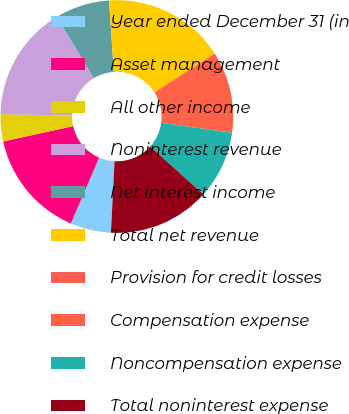Convert chart. <chart><loc_0><loc_0><loc_500><loc_500><pie_chart><fcel>Year ended December 31 (in<fcel>Asset management<fcel>All other income<fcel>Noninterest revenue<fcel>Net interest income<fcel>Total net revenue<fcel>Provision for credit losses<fcel>Compensation expense<fcel>Noncompensation expense<fcel>Total noninterest expense<nl><fcel>5.66%<fcel>15.09%<fcel>3.77%<fcel>16.04%<fcel>7.55%<fcel>16.98%<fcel>0.0%<fcel>11.32%<fcel>9.43%<fcel>14.15%<nl></chart> 